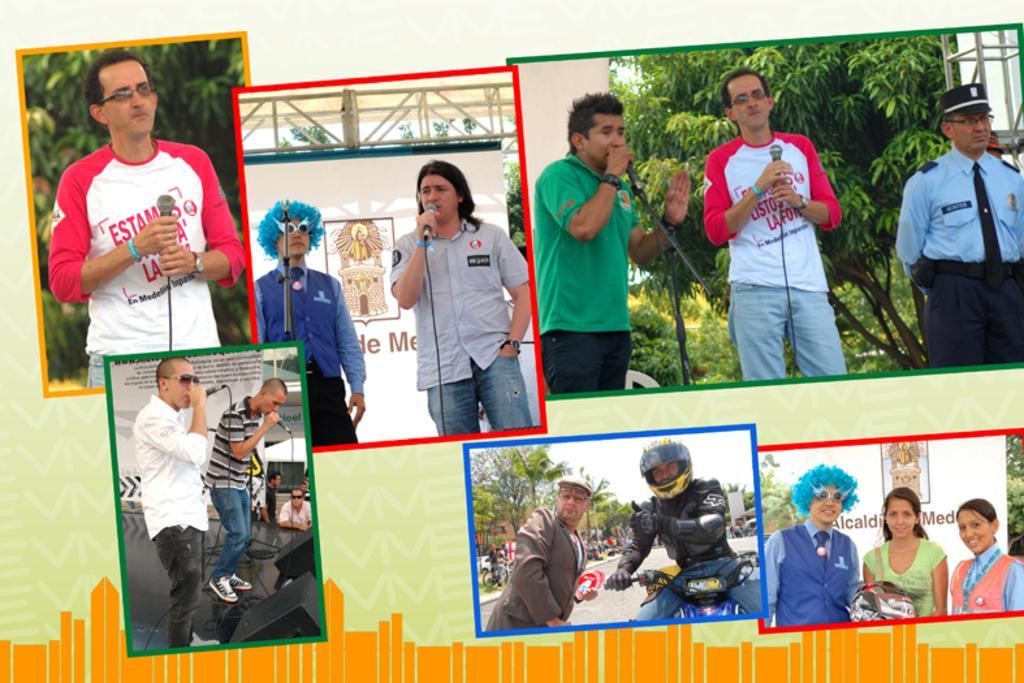In one or two sentences, can you explain what this image depicts? This picture shows a collage of few pictures and we see all the people in the pictures holding microphones and singing and we see trees and a man riding a motorcycle and he wore a helmet on his head and few are standing. 